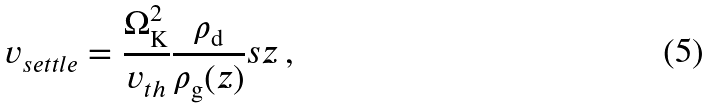Convert formula to latex. <formula><loc_0><loc_0><loc_500><loc_500>v _ { s e t t l e } = \frac { \Omega _ { \mathrm K } ^ { 2 } } { v _ { t h } } \frac { \rho _ { \mathrm d } } { \rho _ { \mathrm g } ( z ) } s z \, ,</formula> 